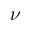Convert formula to latex. <formula><loc_0><loc_0><loc_500><loc_500>\nu</formula> 